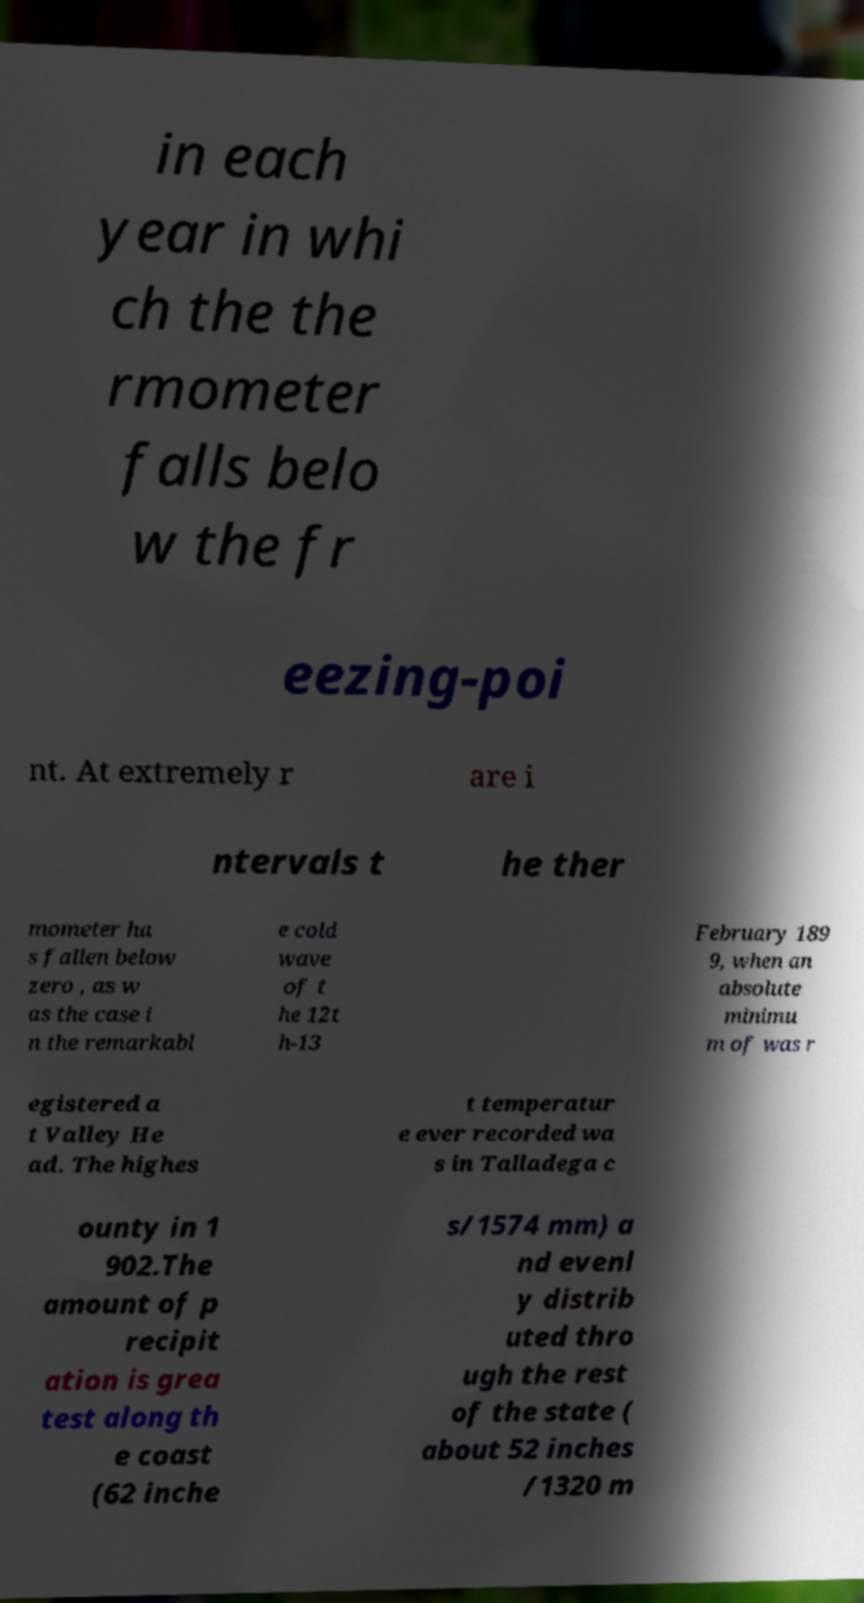I need the written content from this picture converted into text. Can you do that? in each year in whi ch the the rmometer falls belo w the fr eezing-poi nt. At extremely r are i ntervals t he ther mometer ha s fallen below zero , as w as the case i n the remarkabl e cold wave of t he 12t h-13 February 189 9, when an absolute minimu m of was r egistered a t Valley He ad. The highes t temperatur e ever recorded wa s in Talladega c ounty in 1 902.The amount of p recipit ation is grea test along th e coast (62 inche s/1574 mm) a nd evenl y distrib uted thro ugh the rest of the state ( about 52 inches /1320 m 